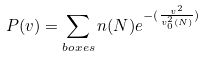<formula> <loc_0><loc_0><loc_500><loc_500>P ( v ) = \sum _ { b o x e s } n ( N ) e ^ { - ( \frac { v ^ { 2 } } { v _ { 0 } ^ { 2 } ( N ) } ) }</formula> 